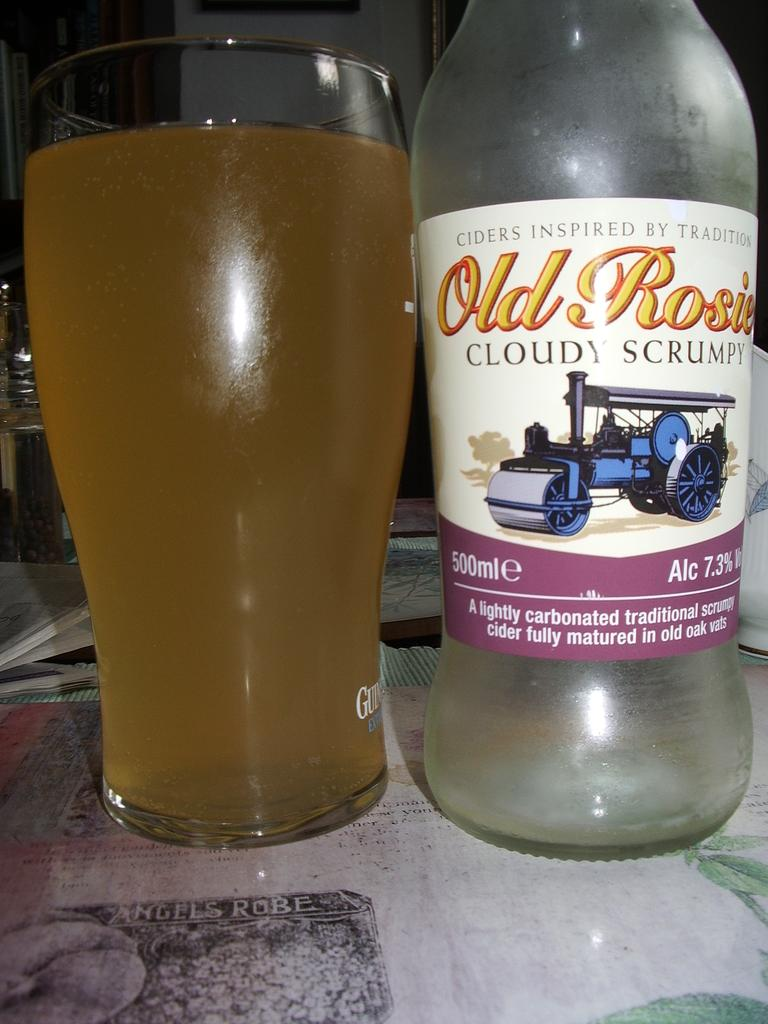Provide a one-sentence caption for the provided image. A glass filled with Old Rosie placed next to the bottle. 